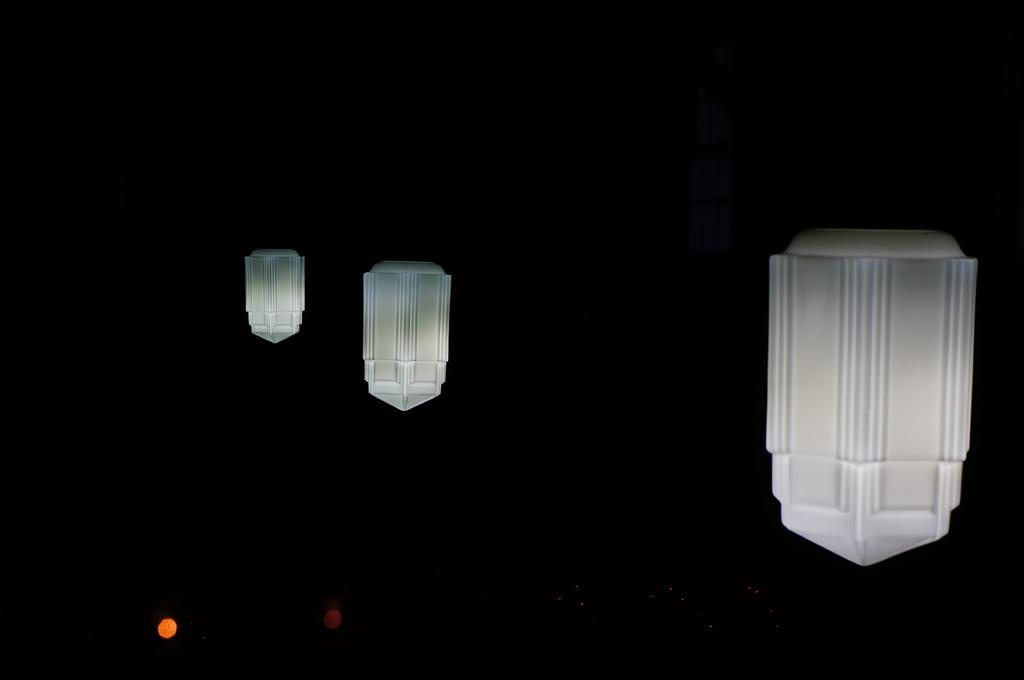How many lights are on the left side of the image? There are two yellow and white color lights arranged on the left side. What color is the light on the right side of the image? There is a white color light arranged on the right side. What can be observed about the background of the image? The background of the image is dark in color. What type of bread is being used to create the bead necklace in the image? There is no bread or bead necklace present in the image; it features lights arranged on both sides. 